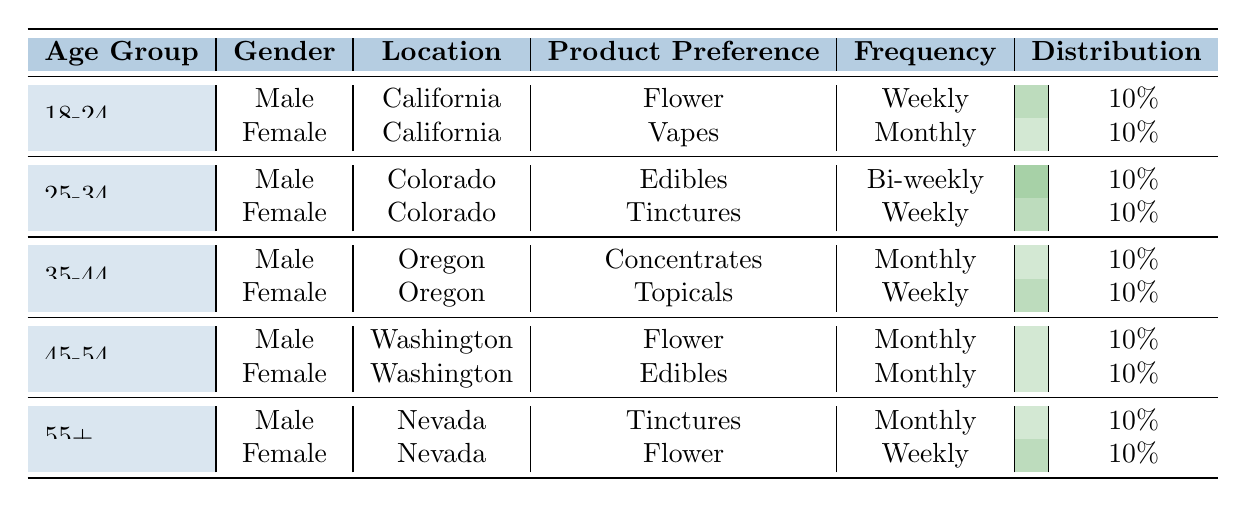What product do males aged 18-24 in California prefer? The table shows that males aged 18-24 from California have a product preference for Flower. This can be directly found in the row where the age group, gender, and location are specified.
Answer: Flower How many different product preferences are there for females aged 35-44? For females aged 35-44, there is one product preference listed in the table, which is Topicals. Therefore, the count is 1.
Answer: 1 Is there anyone who prefers Tinctures on a weekly basis? The table indicates that Tinctures are preferred by a female aged 25-34 (who uses them weekly) and a male aged 55+ (who uses them monthly). Since the question is about weekly preference, the answer is no, as no one prefers Tinctures weekly.
Answer: No Which age group has both males and females preferring Flower? The table reveals that the age group 55+ has a female preferring Flower (from Nevada) and an 18-24 male also preferring Flower (from California). This means both gender preferences for Flower are in different age groups, but both groups are mentioned. The answer should be the specific age groups provided.
Answer: 18-24 and 55+ What is the total frequency of product preference for males compared to females? By examining the table, the male product frequencies are Weekly, Bi-weekly, Monthly, Monthly, and Monthly, which totals 4 times. For females, the frequencies listed are Monthly, Weekly, Weekly, Monthly, and Weekly, totaling 4 times as well. Therefore, there is an equal total frequency count for both genders.
Answer: Equal (4 times each) What percentage of product preference for the age group 45-54 is accounted for by males? There are two product preferences listed for the age group 45-54, one for males (Flower, Monthly) and one for females (Edibles, Monthly). As males account for only 1 of the 2 preferences, the percentage is (1/2) * 100% = 50%.
Answer: 50% Is the frequency of product preference for Tinctures and Topicals on a weekly basis higher than for Edibles and Flower? The frequencies listed in the table for Tinctures (monthly) and Topicals (weekly) give one preference that is weekly and one that is not, while Edibles (monthly) and Flower (monthly) also provide only one preference that is monthly. Therefore, the comparison shows that 1 weekly preference (Topicals) does not exceed 2 monthly preferences (Edibles and Flower).
Answer: No How many products are preferred by customers aged 25-34 or older? Looking at the age groups of 25-34, which has two preferences (Edibles and Tinctures), and the age group of 35-44 which has also two preferences (Concentrates and Topicals), as well as the group 45-54 (Flower and Edibles) accounting for another two products, and finally the age group 55+ (two products). Altogether, this sums up to 8 distinct products preferred by customers aged 25-34 and older.
Answer: 8 